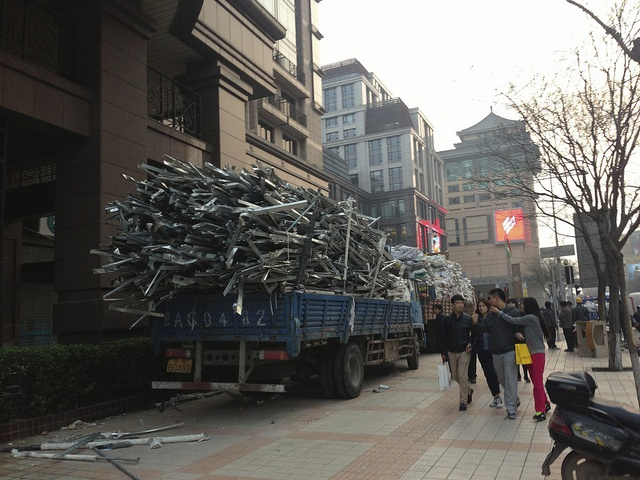Describe the objects in this image and their specific colors. I can see truck in black, gray, and darkblue tones, motorcycle in black, gray, darkgreen, and darkgray tones, people in black, gray, and maroon tones, people in black and gray tones, and people in black, maroon, and gray tones in this image. 